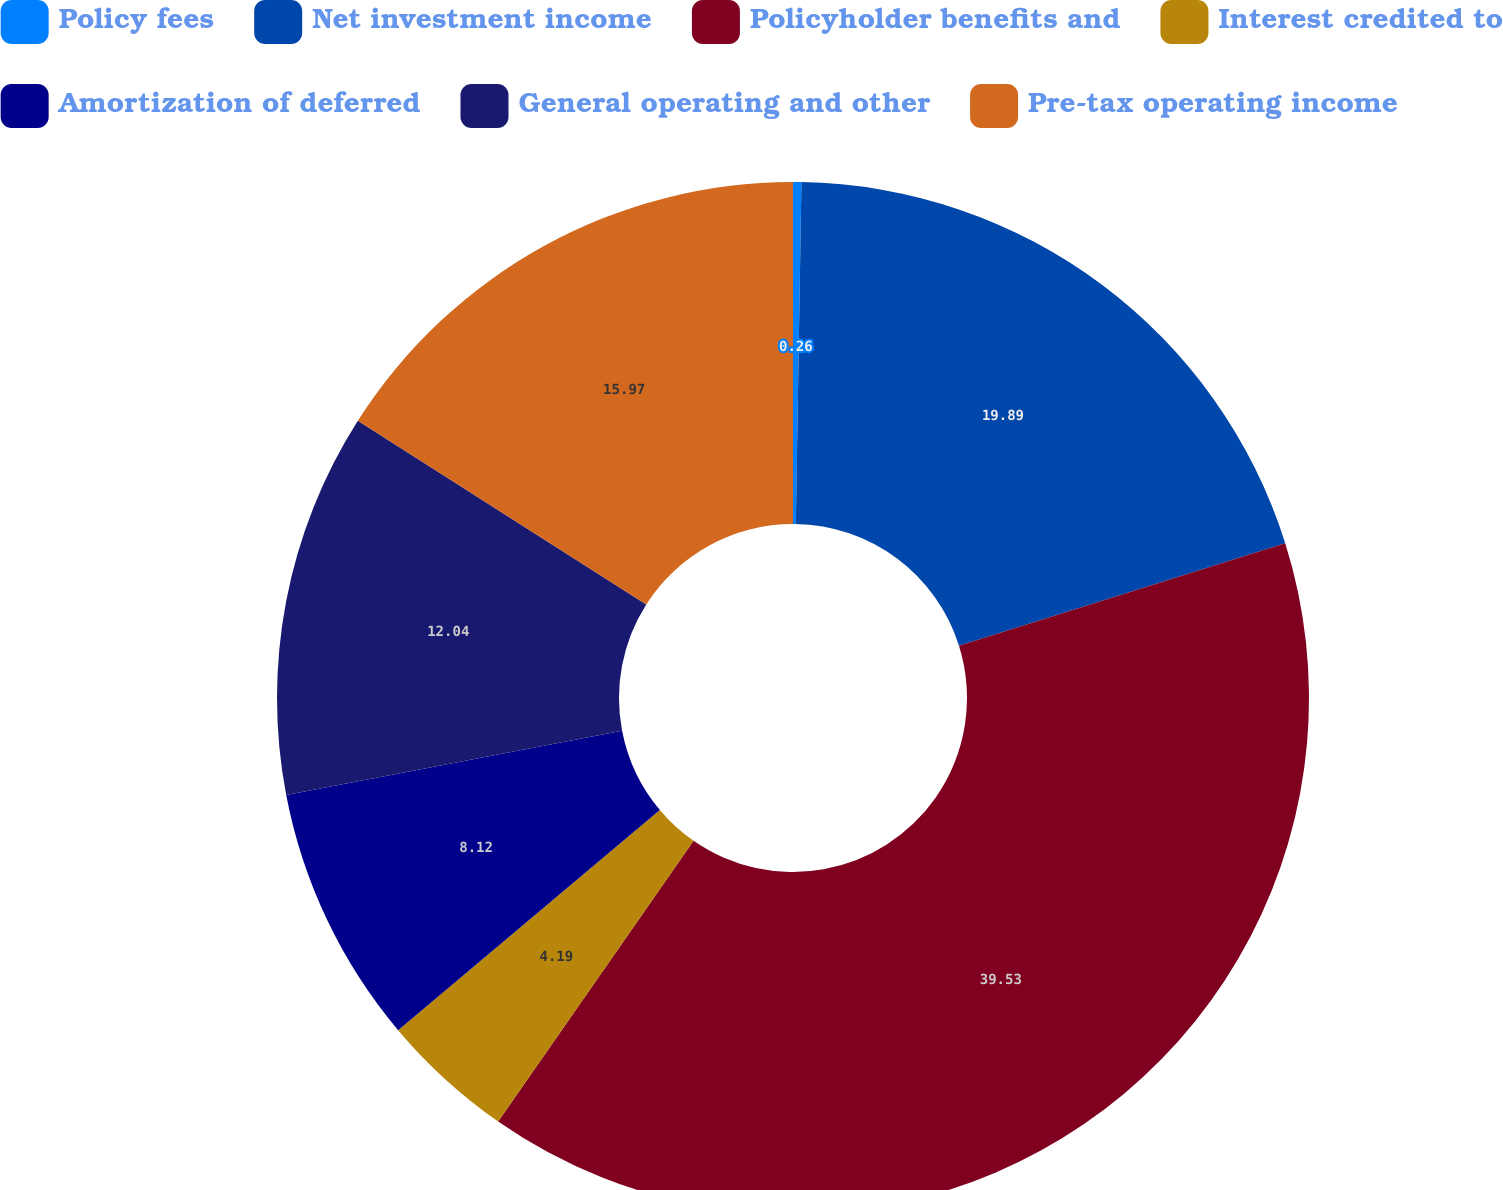Convert chart to OTSL. <chart><loc_0><loc_0><loc_500><loc_500><pie_chart><fcel>Policy fees<fcel>Net investment income<fcel>Policyholder benefits and<fcel>Interest credited to<fcel>Amortization of deferred<fcel>General operating and other<fcel>Pre-tax operating income<nl><fcel>0.26%<fcel>19.89%<fcel>39.53%<fcel>4.19%<fcel>8.12%<fcel>12.04%<fcel>15.97%<nl></chart> 